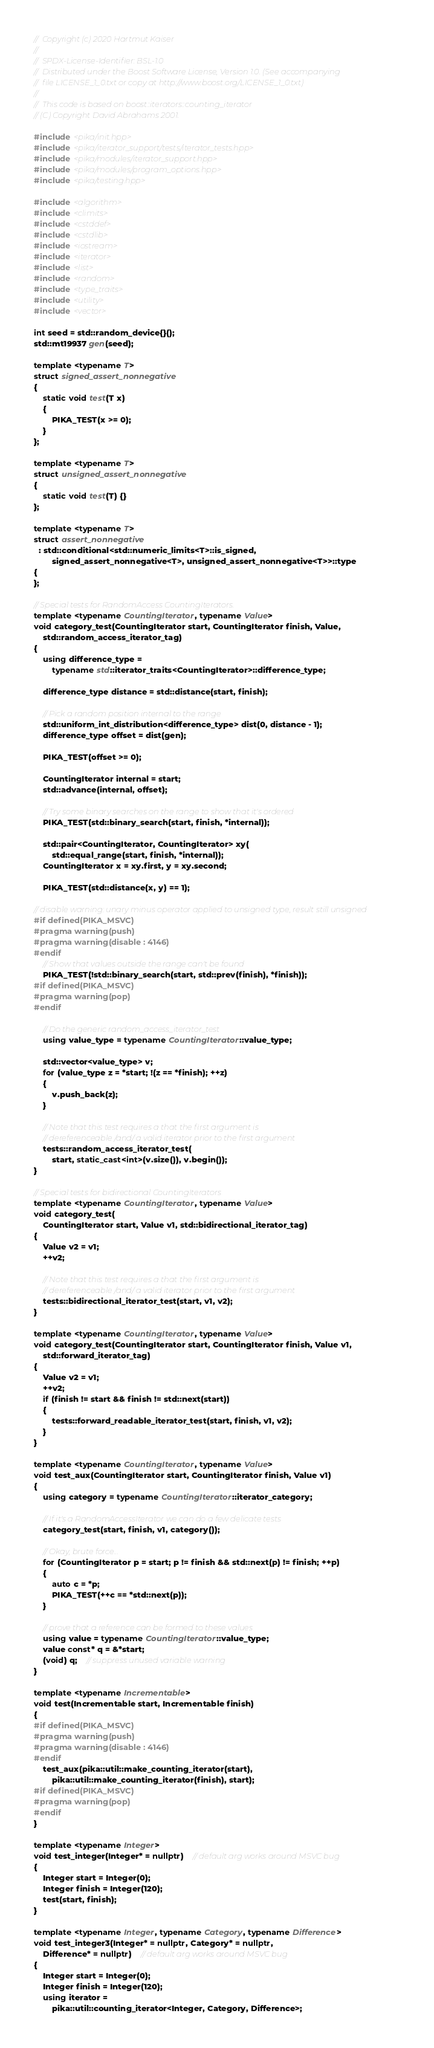Convert code to text. <code><loc_0><loc_0><loc_500><loc_500><_C++_>//  Copyright (c) 2020 Hartmut Kaiser
//
//  SPDX-License-Identifier: BSL-1.0
//  Distributed under the Boost Software License, Version 1.0. (See accompanying
//  file LICENSE_1_0.txt or copy at http://www.boost.org/LICENSE_1_0.txt)
//
//  This code is based on boost::iterators::counting_iterator
// (C) Copyright David Abrahams 2001.

#include <pika/init.hpp>
#include <pika/iterator_support/tests/iterator_tests.hpp>
#include <pika/modules/iterator_support.hpp>
#include <pika/modules/program_options.hpp>
#include <pika/testing.hpp>

#include <algorithm>
#include <climits>
#include <cstddef>
#include <cstdlib>
#include <iostream>
#include <iterator>
#include <list>
#include <random>
#include <type_traits>
#include <utility>
#include <vector>

int seed = std::random_device{}();
std::mt19937 gen(seed);

template <typename T>
struct signed_assert_nonnegative
{
    static void test(T x)
    {
        PIKA_TEST(x >= 0);
    }
};

template <typename T>
struct unsigned_assert_nonnegative
{
    static void test(T) {}
};

template <typename T>
struct assert_nonnegative
  : std::conditional<std::numeric_limits<T>::is_signed,
        signed_assert_nonnegative<T>, unsigned_assert_nonnegative<T>>::type
{
};

// Special tests for RandomAccess CountingIterators.
template <typename CountingIterator, typename Value>
void category_test(CountingIterator start, CountingIterator finish, Value,
    std::random_access_iterator_tag)
{
    using difference_type =
        typename std::iterator_traits<CountingIterator>::difference_type;

    difference_type distance = std::distance(start, finish);

    // Pick a random position internal to the range
    std::uniform_int_distribution<difference_type> dist(0, distance - 1);
    difference_type offset = dist(gen);

    PIKA_TEST(offset >= 0);

    CountingIterator internal = start;
    std::advance(internal, offset);

    // Try some binary searches on the range to show that it's ordered
    PIKA_TEST(std::binary_search(start, finish, *internal));

    std::pair<CountingIterator, CountingIterator> xy(
        std::equal_range(start, finish, *internal));
    CountingIterator x = xy.first, y = xy.second;

    PIKA_TEST(std::distance(x, y) == 1);

// disable warning: unary minus operator applied to unsigned type, result still unsigned
#if defined(PIKA_MSVC)
#pragma warning(push)
#pragma warning(disable : 4146)
#endif
    // Show that values outside the range can't be found
    PIKA_TEST(!std::binary_search(start, std::prev(finish), *finish));
#if defined(PIKA_MSVC)
#pragma warning(pop)
#endif

    // Do the generic random_access_iterator_test
    using value_type = typename CountingIterator::value_type;

    std::vector<value_type> v;
    for (value_type z = *start; !(z == *finish); ++z)
    {
        v.push_back(z);
    }

    // Note that this test requires a that the first argument is
    // dereferenceable /and/ a valid iterator prior to the first argument
    tests::random_access_iterator_test(
        start, static_cast<int>(v.size()), v.begin());
}

// Special tests for bidirectional CountingIterators
template <typename CountingIterator, typename Value>
void category_test(
    CountingIterator start, Value v1, std::bidirectional_iterator_tag)
{
    Value v2 = v1;
    ++v2;

    // Note that this test requires a that the first argument is
    // dereferenceable /and/ a valid iterator prior to the first argument
    tests::bidirectional_iterator_test(start, v1, v2);
}

template <typename CountingIterator, typename Value>
void category_test(CountingIterator start, CountingIterator finish, Value v1,
    std::forward_iterator_tag)
{
    Value v2 = v1;
    ++v2;
    if (finish != start && finish != std::next(start))
    {
        tests::forward_readable_iterator_test(start, finish, v1, v2);
    }
}

template <typename CountingIterator, typename Value>
void test_aux(CountingIterator start, CountingIterator finish, Value v1)
{
    using category = typename CountingIterator::iterator_category;

    // If it's a RandomAccessIterator we can do a few delicate tests
    category_test(start, finish, v1, category());

    // Okay, brute force...
    for (CountingIterator p = start; p != finish && std::next(p) != finish; ++p)
    {
        auto c = *p;
        PIKA_TEST(++c == *std::next(p));
    }

    // prove that a reference can be formed to these values
    using value = typename CountingIterator::value_type;
    value const* q = &*start;
    (void) q;    // suppress unused variable warning
}

template <typename Incrementable>
void test(Incrementable start, Incrementable finish)
{
#if defined(PIKA_MSVC)
#pragma warning(push)
#pragma warning(disable : 4146)
#endif
    test_aux(pika::util::make_counting_iterator(start),
        pika::util::make_counting_iterator(finish), start);
#if defined(PIKA_MSVC)
#pragma warning(pop)
#endif
}

template <typename Integer>
void test_integer(Integer* = nullptr)    // default arg works around MSVC bug
{
    Integer start = Integer(0);
    Integer finish = Integer(120);
    test(start, finish);
}

template <typename Integer, typename Category, typename Difference>
void test_integer3(Integer* = nullptr, Category* = nullptr,
    Difference* = nullptr)    // default arg works around MSVC bug
{
    Integer start = Integer(0);
    Integer finish = Integer(120);
    using iterator =
        pika::util::counting_iterator<Integer, Category, Difference>;</code> 